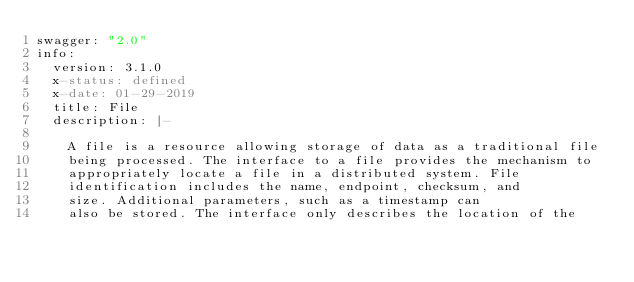Convert code to text. <code><loc_0><loc_0><loc_500><loc_500><_YAML_>swagger: "2.0"
info:
  version: 3.1.0
  x-status: defined
  x-date: 01-29-2019  
  title: File
  description: |-
  
    A file is a resource allowing storage of data as a traditional file
    being processed. The interface to a file provides the mechanism to
    appropriately locate a file in a distributed system. File
    identification includes the name, endpoint, checksum, and
    size. Additional parameters, such as a timestamp can
    also be stored. The interface only describes the location of the</code> 